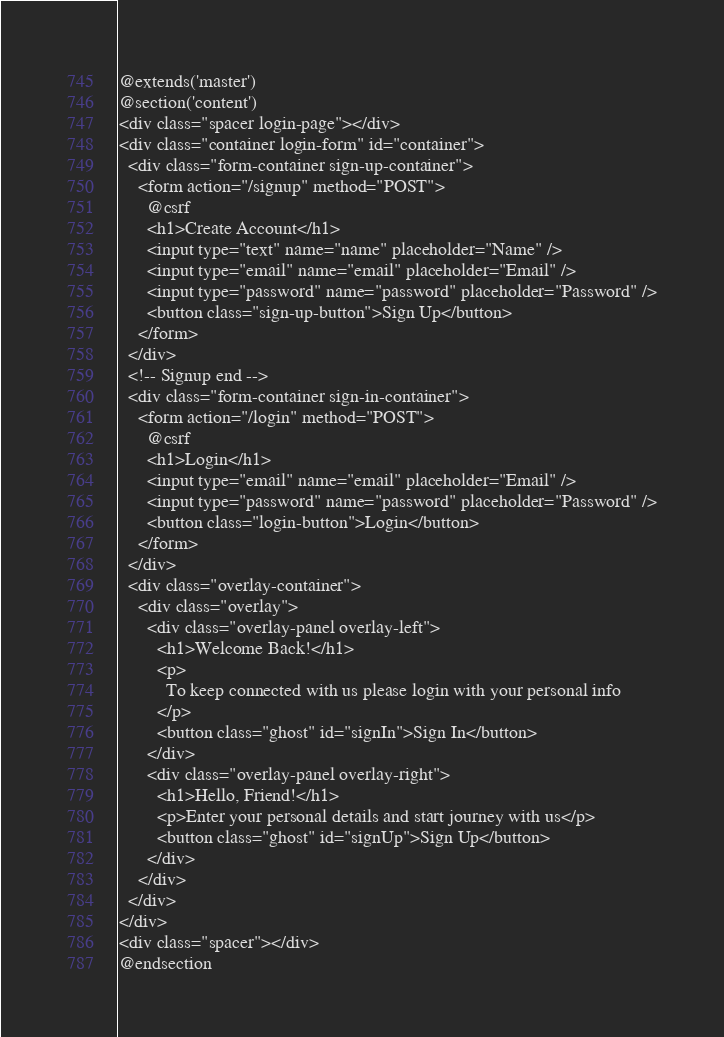Convert code to text. <code><loc_0><loc_0><loc_500><loc_500><_PHP_>@extends('master')
@section('content')
<div class="spacer login-page"></div>
<div class="container login-form" id="container">
  <div class="form-container sign-up-container">
    <form action="/signup" method="POST">
      @csrf
      <h1>Create Account</h1>
      <input type="text" name="name" placeholder="Name" />
      <input type="email" name="email" placeholder="Email" />
      <input type="password" name="password" placeholder="Password" />
      <button class="sign-up-button">Sign Up</button>
    </form>
  </div>
  <!-- Signup end -->
  <div class="form-container sign-in-container">
    <form action="/login" method="POST">
      @csrf
      <h1>Login</h1>
      <input type="email" name="email" placeholder="Email" />
      <input type="password" name="password" placeholder="Password" />
      <button class="login-button">Login</button>
    </form>
  </div>
  <div class="overlay-container">
    <div class="overlay">
      <div class="overlay-panel overlay-left">
        <h1>Welcome Back!</h1>
        <p>
          To keep connected with us please login with your personal info
        </p>
        <button class="ghost" id="signIn">Sign In</button>
      </div>
      <div class="overlay-panel overlay-right">
        <h1>Hello, Friend!</h1>
        <p>Enter your personal details and start journey with us</p>
        <button class="ghost" id="signUp">Sign Up</button>
      </div>
    </div>
  </div>
</div>
<div class="spacer"></div>
@endsection

</code> 